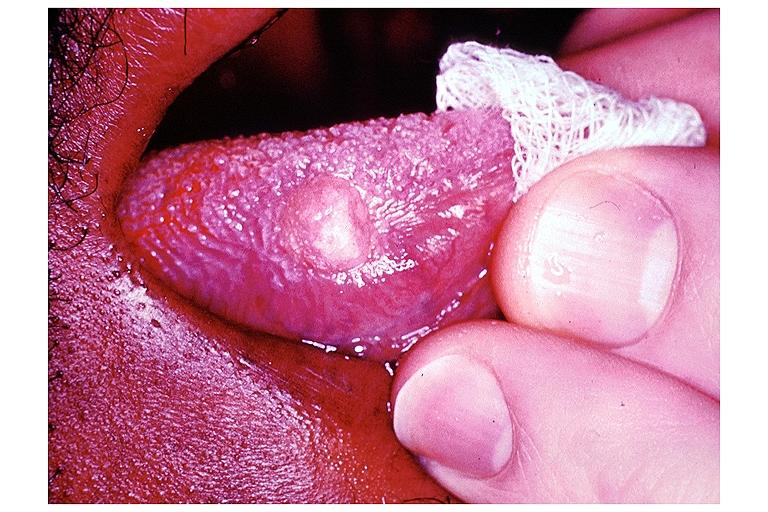s lymphoblastic lymphoma present?
Answer the question using a single word or phrase. No 